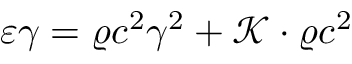<formula> <loc_0><loc_0><loc_500><loc_500>\varepsilon \gamma = \varrho c ^ { 2 } \gamma ^ { 2 } + \mathcal { K } \cdot \varrho c ^ { 2 }</formula> 